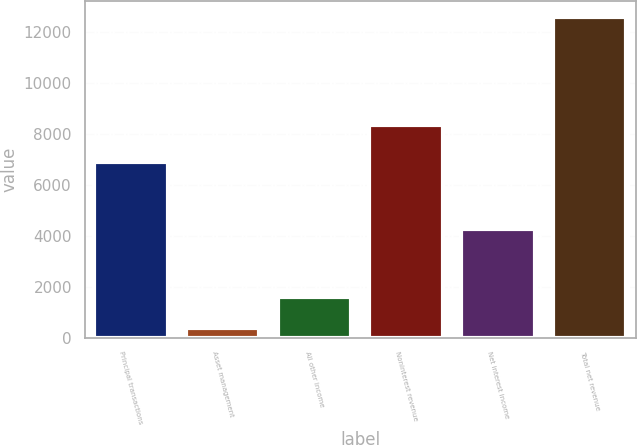<chart> <loc_0><loc_0><loc_500><loc_500><bar_chart><fcel>Principal transactions<fcel>Asset management<fcel>All other income<fcel>Noninterest revenue<fcel>Net interest income<fcel>Total net revenue<nl><fcel>6899<fcel>383<fcel>1603.9<fcel>8330<fcel>4262<fcel>12592<nl></chart> 